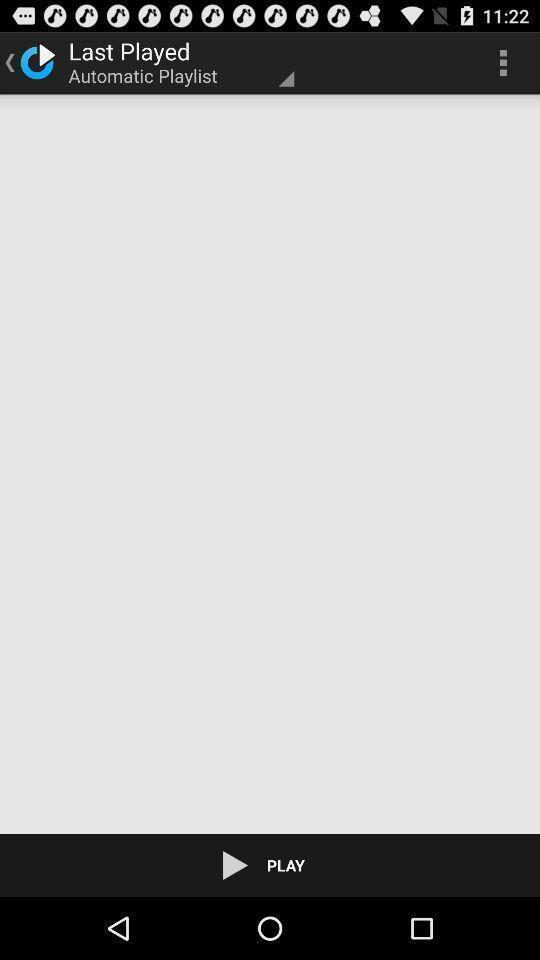Describe the key features of this screenshot. Screen displaying last played page. 